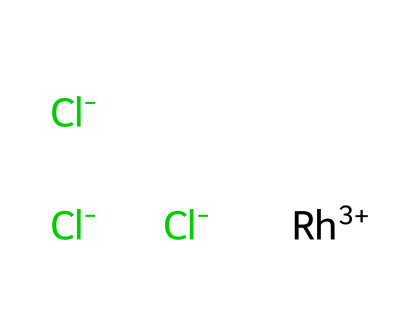What is the central metal ion in this coordination compound? The central metal ion is identified as rhodium, which can be inferred from its designation in the chemical notation as Rh.
Answer: rhodium How many chloride ions are present in this compound? The SMILES representation includes three chloride ions, indicated by the three occurrences of Cl within the structure.
Answer: three What is the oxidation state of rhodium in this compound? The notation Rh+3 indicates that rhodium has an oxidation state of +3, which reflects the loss of three electrons.
Answer: +3 Is this compound neutral, cationic, or anionic? To determine this, we must evaluate the charge balance: Rh is +3 and there are three Cl ions at -1 each, totaling -3; this combination results in a net charge of 0, thus making the compound neutral.
Answer: neutral What type of coordination does the chloride ion exhibit with rhodium in this complex? The chloride ions act as ligands in this coordination complex, coordinating through their lone pairs to the rhodium ion, which allows for electron sharing.
Answer: ligand coordination How many total atoms are in the structure? The total atom count includes one rhodium atom and three chloride atoms, adding up to four atoms in total within the structure.
Answer: four 